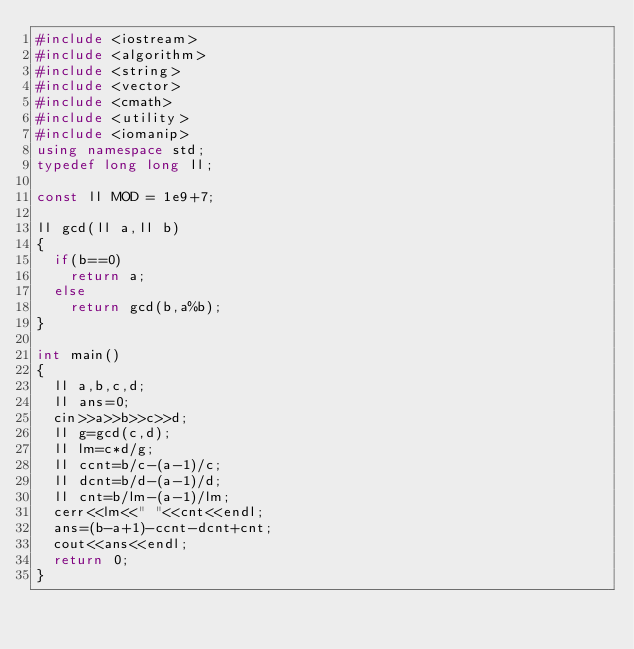<code> <loc_0><loc_0><loc_500><loc_500><_C++_>#include <iostream>
#include <algorithm>
#include <string>
#include <vector>
#include <cmath>
#include <utility>
#include <iomanip>
using namespace std;
typedef long long ll;

const ll MOD = 1e9+7;

ll gcd(ll a,ll b)
{
	if(b==0)
		return a;
	else
		return gcd(b,a%b);
}

int main()
{
	ll a,b,c,d;
	ll ans=0;
	cin>>a>>b>>c>>d;
	ll g=gcd(c,d);
	ll lm=c*d/g;
	ll ccnt=b/c-(a-1)/c;
	ll dcnt=b/d-(a-1)/d;
	ll cnt=b/lm-(a-1)/lm;
	cerr<<lm<<" "<<cnt<<endl;
	ans=(b-a+1)-ccnt-dcnt+cnt;
	cout<<ans<<endl;
	return 0;
}</code> 